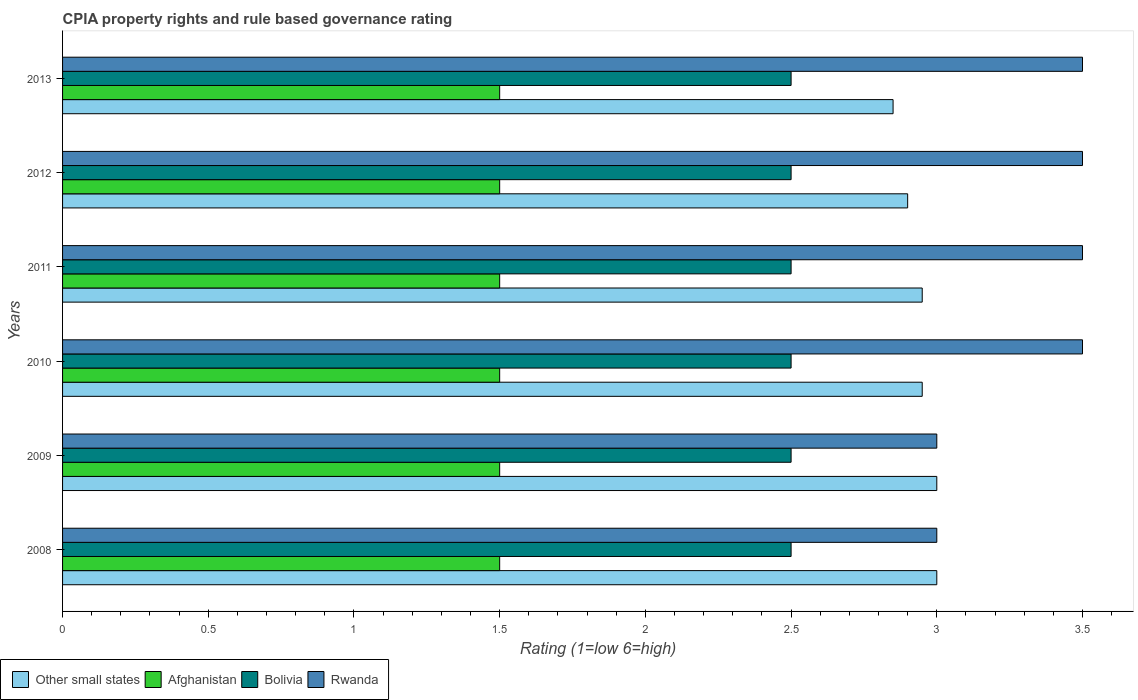How many different coloured bars are there?
Keep it short and to the point. 4. Are the number of bars per tick equal to the number of legend labels?
Your response must be concise. Yes. How many bars are there on the 3rd tick from the bottom?
Your answer should be compact. 4. What is the CPIA rating in Rwanda in 2012?
Offer a terse response. 3.5. Across all years, what is the maximum CPIA rating in Rwanda?
Ensure brevity in your answer.  3.5. Across all years, what is the minimum CPIA rating in Rwanda?
Provide a succinct answer. 3. In which year was the CPIA rating in Rwanda minimum?
Make the answer very short. 2008. What is the total CPIA rating in Other small states in the graph?
Provide a succinct answer. 17.65. What is the difference between the CPIA rating in Other small states in 2011 and the CPIA rating in Bolivia in 2012?
Your answer should be very brief. 0.45. What is the average CPIA rating in Other small states per year?
Keep it short and to the point. 2.94. In the year 2011, what is the difference between the CPIA rating in Rwanda and CPIA rating in Afghanistan?
Make the answer very short. 2. What is the ratio of the CPIA rating in Rwanda in 2010 to that in 2012?
Provide a succinct answer. 1. Is the CPIA rating in Other small states in 2009 less than that in 2012?
Make the answer very short. No. Is the difference between the CPIA rating in Rwanda in 2008 and 2013 greater than the difference between the CPIA rating in Afghanistan in 2008 and 2013?
Offer a very short reply. No. In how many years, is the CPIA rating in Other small states greater than the average CPIA rating in Other small states taken over all years?
Offer a very short reply. 4. What does the 4th bar from the top in 2012 represents?
Your answer should be compact. Other small states. What does the 2nd bar from the bottom in 2012 represents?
Your answer should be very brief. Afghanistan. How many bars are there?
Your answer should be compact. 24. How many years are there in the graph?
Your response must be concise. 6. Does the graph contain grids?
Ensure brevity in your answer.  No. How many legend labels are there?
Offer a terse response. 4. How are the legend labels stacked?
Provide a succinct answer. Horizontal. What is the title of the graph?
Offer a very short reply. CPIA property rights and rule based governance rating. Does "Australia" appear as one of the legend labels in the graph?
Offer a very short reply. No. What is the Rating (1=low 6=high) of Other small states in 2008?
Your response must be concise. 3. What is the Rating (1=low 6=high) in Afghanistan in 2008?
Provide a succinct answer. 1.5. What is the Rating (1=low 6=high) in Other small states in 2009?
Provide a short and direct response. 3. What is the Rating (1=low 6=high) in Afghanistan in 2009?
Make the answer very short. 1.5. What is the Rating (1=low 6=high) in Bolivia in 2009?
Give a very brief answer. 2.5. What is the Rating (1=low 6=high) of Other small states in 2010?
Offer a very short reply. 2.95. What is the Rating (1=low 6=high) of Bolivia in 2010?
Your answer should be compact. 2.5. What is the Rating (1=low 6=high) of Other small states in 2011?
Provide a short and direct response. 2.95. What is the Rating (1=low 6=high) of Bolivia in 2011?
Your answer should be very brief. 2.5. What is the Rating (1=low 6=high) in Rwanda in 2011?
Provide a short and direct response. 3.5. What is the Rating (1=low 6=high) in Other small states in 2012?
Your answer should be compact. 2.9. What is the Rating (1=low 6=high) of Rwanda in 2012?
Offer a very short reply. 3.5. What is the Rating (1=low 6=high) of Other small states in 2013?
Keep it short and to the point. 2.85. What is the Rating (1=low 6=high) of Afghanistan in 2013?
Offer a terse response. 1.5. What is the Rating (1=low 6=high) of Bolivia in 2013?
Give a very brief answer. 2.5. What is the Rating (1=low 6=high) in Rwanda in 2013?
Your answer should be very brief. 3.5. Across all years, what is the maximum Rating (1=low 6=high) of Other small states?
Give a very brief answer. 3. Across all years, what is the maximum Rating (1=low 6=high) of Rwanda?
Provide a succinct answer. 3.5. Across all years, what is the minimum Rating (1=low 6=high) in Other small states?
Your answer should be compact. 2.85. Across all years, what is the minimum Rating (1=low 6=high) of Rwanda?
Your response must be concise. 3. What is the total Rating (1=low 6=high) in Other small states in the graph?
Provide a short and direct response. 17.65. What is the total Rating (1=low 6=high) of Bolivia in the graph?
Provide a short and direct response. 15. What is the total Rating (1=low 6=high) in Rwanda in the graph?
Your response must be concise. 20. What is the difference between the Rating (1=low 6=high) of Other small states in 2008 and that in 2009?
Offer a very short reply. 0. What is the difference between the Rating (1=low 6=high) of Other small states in 2008 and that in 2010?
Your answer should be compact. 0.05. What is the difference between the Rating (1=low 6=high) in Rwanda in 2008 and that in 2010?
Your answer should be compact. -0.5. What is the difference between the Rating (1=low 6=high) of Bolivia in 2008 and that in 2012?
Your answer should be compact. 0. What is the difference between the Rating (1=low 6=high) of Rwanda in 2008 and that in 2012?
Make the answer very short. -0.5. What is the difference between the Rating (1=low 6=high) of Other small states in 2008 and that in 2013?
Keep it short and to the point. 0.15. What is the difference between the Rating (1=low 6=high) in Rwanda in 2008 and that in 2013?
Provide a succinct answer. -0.5. What is the difference between the Rating (1=low 6=high) in Rwanda in 2009 and that in 2010?
Your answer should be compact. -0.5. What is the difference between the Rating (1=low 6=high) in Other small states in 2009 and that in 2011?
Give a very brief answer. 0.05. What is the difference between the Rating (1=low 6=high) of Bolivia in 2009 and that in 2011?
Your answer should be very brief. 0. What is the difference between the Rating (1=low 6=high) in Rwanda in 2009 and that in 2011?
Provide a short and direct response. -0.5. What is the difference between the Rating (1=low 6=high) of Afghanistan in 2009 and that in 2012?
Offer a very short reply. 0. What is the difference between the Rating (1=low 6=high) in Bolivia in 2009 and that in 2012?
Provide a short and direct response. 0. What is the difference between the Rating (1=low 6=high) of Rwanda in 2009 and that in 2012?
Offer a very short reply. -0.5. What is the difference between the Rating (1=low 6=high) in Afghanistan in 2009 and that in 2013?
Make the answer very short. 0. What is the difference between the Rating (1=low 6=high) of Afghanistan in 2010 and that in 2011?
Provide a succinct answer. 0. What is the difference between the Rating (1=low 6=high) in Other small states in 2010 and that in 2012?
Provide a short and direct response. 0.05. What is the difference between the Rating (1=low 6=high) of Other small states in 2010 and that in 2013?
Offer a very short reply. 0.1. What is the difference between the Rating (1=low 6=high) in Afghanistan in 2010 and that in 2013?
Provide a short and direct response. 0. What is the difference between the Rating (1=low 6=high) in Bolivia in 2010 and that in 2013?
Offer a very short reply. 0. What is the difference between the Rating (1=low 6=high) of Rwanda in 2010 and that in 2013?
Offer a terse response. 0. What is the difference between the Rating (1=low 6=high) of Afghanistan in 2011 and that in 2012?
Keep it short and to the point. 0. What is the difference between the Rating (1=low 6=high) of Other small states in 2011 and that in 2013?
Provide a succinct answer. 0.1. What is the difference between the Rating (1=low 6=high) in Afghanistan in 2011 and that in 2013?
Provide a short and direct response. 0. What is the difference between the Rating (1=low 6=high) in Other small states in 2012 and that in 2013?
Make the answer very short. 0.05. What is the difference between the Rating (1=low 6=high) in Bolivia in 2012 and that in 2013?
Ensure brevity in your answer.  0. What is the difference between the Rating (1=low 6=high) of Other small states in 2008 and the Rating (1=low 6=high) of Afghanistan in 2009?
Offer a terse response. 1.5. What is the difference between the Rating (1=low 6=high) of Other small states in 2008 and the Rating (1=low 6=high) of Bolivia in 2009?
Provide a succinct answer. 0.5. What is the difference between the Rating (1=low 6=high) in Afghanistan in 2008 and the Rating (1=low 6=high) in Bolivia in 2009?
Offer a very short reply. -1. What is the difference between the Rating (1=low 6=high) in Bolivia in 2008 and the Rating (1=low 6=high) in Rwanda in 2009?
Offer a terse response. -0.5. What is the difference between the Rating (1=low 6=high) of Other small states in 2008 and the Rating (1=low 6=high) of Afghanistan in 2010?
Provide a short and direct response. 1.5. What is the difference between the Rating (1=low 6=high) of Afghanistan in 2008 and the Rating (1=low 6=high) of Rwanda in 2010?
Your answer should be compact. -2. What is the difference between the Rating (1=low 6=high) of Bolivia in 2008 and the Rating (1=low 6=high) of Rwanda in 2010?
Make the answer very short. -1. What is the difference between the Rating (1=low 6=high) of Other small states in 2008 and the Rating (1=low 6=high) of Afghanistan in 2011?
Your answer should be very brief. 1.5. What is the difference between the Rating (1=low 6=high) in Other small states in 2008 and the Rating (1=low 6=high) in Bolivia in 2011?
Ensure brevity in your answer.  0.5. What is the difference between the Rating (1=low 6=high) in Afghanistan in 2008 and the Rating (1=low 6=high) in Rwanda in 2011?
Give a very brief answer. -2. What is the difference between the Rating (1=low 6=high) in Bolivia in 2008 and the Rating (1=low 6=high) in Rwanda in 2011?
Give a very brief answer. -1. What is the difference between the Rating (1=low 6=high) in Other small states in 2008 and the Rating (1=low 6=high) in Afghanistan in 2012?
Offer a very short reply. 1.5. What is the difference between the Rating (1=low 6=high) in Other small states in 2008 and the Rating (1=low 6=high) in Bolivia in 2012?
Give a very brief answer. 0.5. What is the difference between the Rating (1=low 6=high) of Afghanistan in 2008 and the Rating (1=low 6=high) of Bolivia in 2012?
Give a very brief answer. -1. What is the difference between the Rating (1=low 6=high) of Bolivia in 2008 and the Rating (1=low 6=high) of Rwanda in 2012?
Your answer should be compact. -1. What is the difference between the Rating (1=low 6=high) in Other small states in 2008 and the Rating (1=low 6=high) in Afghanistan in 2013?
Your answer should be compact. 1.5. What is the difference between the Rating (1=low 6=high) in Bolivia in 2008 and the Rating (1=low 6=high) in Rwanda in 2013?
Make the answer very short. -1. What is the difference between the Rating (1=low 6=high) of Other small states in 2009 and the Rating (1=low 6=high) of Afghanistan in 2010?
Provide a short and direct response. 1.5. What is the difference between the Rating (1=low 6=high) in Other small states in 2009 and the Rating (1=low 6=high) in Rwanda in 2010?
Your response must be concise. -0.5. What is the difference between the Rating (1=low 6=high) of Bolivia in 2009 and the Rating (1=low 6=high) of Rwanda in 2010?
Your answer should be compact. -1. What is the difference between the Rating (1=low 6=high) in Other small states in 2009 and the Rating (1=low 6=high) in Rwanda in 2011?
Your response must be concise. -0.5. What is the difference between the Rating (1=low 6=high) in Afghanistan in 2009 and the Rating (1=low 6=high) in Rwanda in 2011?
Offer a terse response. -2. What is the difference between the Rating (1=low 6=high) of Bolivia in 2009 and the Rating (1=low 6=high) of Rwanda in 2011?
Give a very brief answer. -1. What is the difference between the Rating (1=low 6=high) in Other small states in 2009 and the Rating (1=low 6=high) in Afghanistan in 2012?
Give a very brief answer. 1.5. What is the difference between the Rating (1=low 6=high) of Other small states in 2009 and the Rating (1=low 6=high) of Afghanistan in 2013?
Ensure brevity in your answer.  1.5. What is the difference between the Rating (1=low 6=high) in Other small states in 2009 and the Rating (1=low 6=high) in Bolivia in 2013?
Your answer should be very brief. 0.5. What is the difference between the Rating (1=low 6=high) of Other small states in 2009 and the Rating (1=low 6=high) of Rwanda in 2013?
Your answer should be very brief. -0.5. What is the difference between the Rating (1=low 6=high) of Other small states in 2010 and the Rating (1=low 6=high) of Afghanistan in 2011?
Provide a short and direct response. 1.45. What is the difference between the Rating (1=low 6=high) of Other small states in 2010 and the Rating (1=low 6=high) of Bolivia in 2011?
Offer a very short reply. 0.45. What is the difference between the Rating (1=low 6=high) in Other small states in 2010 and the Rating (1=low 6=high) in Rwanda in 2011?
Provide a short and direct response. -0.55. What is the difference between the Rating (1=low 6=high) of Afghanistan in 2010 and the Rating (1=low 6=high) of Bolivia in 2011?
Ensure brevity in your answer.  -1. What is the difference between the Rating (1=low 6=high) in Other small states in 2010 and the Rating (1=low 6=high) in Afghanistan in 2012?
Ensure brevity in your answer.  1.45. What is the difference between the Rating (1=low 6=high) in Other small states in 2010 and the Rating (1=low 6=high) in Bolivia in 2012?
Offer a terse response. 0.45. What is the difference between the Rating (1=low 6=high) of Other small states in 2010 and the Rating (1=low 6=high) of Rwanda in 2012?
Your answer should be very brief. -0.55. What is the difference between the Rating (1=low 6=high) of Bolivia in 2010 and the Rating (1=low 6=high) of Rwanda in 2012?
Your response must be concise. -1. What is the difference between the Rating (1=low 6=high) of Other small states in 2010 and the Rating (1=low 6=high) of Afghanistan in 2013?
Make the answer very short. 1.45. What is the difference between the Rating (1=low 6=high) of Other small states in 2010 and the Rating (1=low 6=high) of Bolivia in 2013?
Give a very brief answer. 0.45. What is the difference between the Rating (1=low 6=high) of Other small states in 2010 and the Rating (1=low 6=high) of Rwanda in 2013?
Keep it short and to the point. -0.55. What is the difference between the Rating (1=low 6=high) in Afghanistan in 2010 and the Rating (1=low 6=high) in Rwanda in 2013?
Give a very brief answer. -2. What is the difference between the Rating (1=low 6=high) of Bolivia in 2010 and the Rating (1=low 6=high) of Rwanda in 2013?
Your response must be concise. -1. What is the difference between the Rating (1=low 6=high) of Other small states in 2011 and the Rating (1=low 6=high) of Afghanistan in 2012?
Offer a very short reply. 1.45. What is the difference between the Rating (1=low 6=high) of Other small states in 2011 and the Rating (1=low 6=high) of Bolivia in 2012?
Provide a short and direct response. 0.45. What is the difference between the Rating (1=low 6=high) of Other small states in 2011 and the Rating (1=low 6=high) of Rwanda in 2012?
Your answer should be very brief. -0.55. What is the difference between the Rating (1=low 6=high) in Afghanistan in 2011 and the Rating (1=low 6=high) in Rwanda in 2012?
Your response must be concise. -2. What is the difference between the Rating (1=low 6=high) of Other small states in 2011 and the Rating (1=low 6=high) of Afghanistan in 2013?
Your answer should be very brief. 1.45. What is the difference between the Rating (1=low 6=high) of Other small states in 2011 and the Rating (1=low 6=high) of Bolivia in 2013?
Offer a terse response. 0.45. What is the difference between the Rating (1=low 6=high) in Other small states in 2011 and the Rating (1=low 6=high) in Rwanda in 2013?
Offer a terse response. -0.55. What is the difference between the Rating (1=low 6=high) in Afghanistan in 2011 and the Rating (1=low 6=high) in Bolivia in 2013?
Offer a terse response. -1. What is the difference between the Rating (1=low 6=high) in Afghanistan in 2011 and the Rating (1=low 6=high) in Rwanda in 2013?
Provide a succinct answer. -2. What is the difference between the Rating (1=low 6=high) in Bolivia in 2011 and the Rating (1=low 6=high) in Rwanda in 2013?
Offer a terse response. -1. What is the difference between the Rating (1=low 6=high) in Other small states in 2012 and the Rating (1=low 6=high) in Afghanistan in 2013?
Provide a short and direct response. 1.4. What is the difference between the Rating (1=low 6=high) of Afghanistan in 2012 and the Rating (1=low 6=high) of Bolivia in 2013?
Offer a very short reply. -1. What is the difference between the Rating (1=low 6=high) in Afghanistan in 2012 and the Rating (1=low 6=high) in Rwanda in 2013?
Your response must be concise. -2. What is the average Rating (1=low 6=high) of Other small states per year?
Provide a succinct answer. 2.94. What is the average Rating (1=low 6=high) of Afghanistan per year?
Provide a succinct answer. 1.5. What is the average Rating (1=low 6=high) of Bolivia per year?
Provide a succinct answer. 2.5. What is the average Rating (1=low 6=high) of Rwanda per year?
Keep it short and to the point. 3.33. In the year 2008, what is the difference between the Rating (1=low 6=high) of Other small states and Rating (1=low 6=high) of Bolivia?
Keep it short and to the point. 0.5. In the year 2008, what is the difference between the Rating (1=low 6=high) of Afghanistan and Rating (1=low 6=high) of Bolivia?
Provide a short and direct response. -1. In the year 2008, what is the difference between the Rating (1=low 6=high) of Afghanistan and Rating (1=low 6=high) of Rwanda?
Give a very brief answer. -1.5. In the year 2008, what is the difference between the Rating (1=low 6=high) in Bolivia and Rating (1=low 6=high) in Rwanda?
Offer a terse response. -0.5. In the year 2009, what is the difference between the Rating (1=low 6=high) in Other small states and Rating (1=low 6=high) in Bolivia?
Make the answer very short. 0.5. In the year 2009, what is the difference between the Rating (1=low 6=high) in Afghanistan and Rating (1=low 6=high) in Bolivia?
Make the answer very short. -1. In the year 2010, what is the difference between the Rating (1=low 6=high) in Other small states and Rating (1=low 6=high) in Afghanistan?
Give a very brief answer. 1.45. In the year 2010, what is the difference between the Rating (1=low 6=high) in Other small states and Rating (1=low 6=high) in Bolivia?
Your answer should be very brief. 0.45. In the year 2010, what is the difference between the Rating (1=low 6=high) of Other small states and Rating (1=low 6=high) of Rwanda?
Provide a succinct answer. -0.55. In the year 2010, what is the difference between the Rating (1=low 6=high) in Bolivia and Rating (1=low 6=high) in Rwanda?
Offer a very short reply. -1. In the year 2011, what is the difference between the Rating (1=low 6=high) in Other small states and Rating (1=low 6=high) in Afghanistan?
Give a very brief answer. 1.45. In the year 2011, what is the difference between the Rating (1=low 6=high) in Other small states and Rating (1=low 6=high) in Bolivia?
Offer a terse response. 0.45. In the year 2011, what is the difference between the Rating (1=low 6=high) of Other small states and Rating (1=low 6=high) of Rwanda?
Keep it short and to the point. -0.55. In the year 2011, what is the difference between the Rating (1=low 6=high) in Afghanistan and Rating (1=low 6=high) in Bolivia?
Provide a short and direct response. -1. In the year 2011, what is the difference between the Rating (1=low 6=high) in Afghanistan and Rating (1=low 6=high) in Rwanda?
Your answer should be compact. -2. In the year 2012, what is the difference between the Rating (1=low 6=high) of Other small states and Rating (1=low 6=high) of Rwanda?
Ensure brevity in your answer.  -0.6. In the year 2012, what is the difference between the Rating (1=low 6=high) of Afghanistan and Rating (1=low 6=high) of Rwanda?
Make the answer very short. -2. In the year 2013, what is the difference between the Rating (1=low 6=high) in Other small states and Rating (1=low 6=high) in Afghanistan?
Ensure brevity in your answer.  1.35. In the year 2013, what is the difference between the Rating (1=low 6=high) of Other small states and Rating (1=low 6=high) of Rwanda?
Provide a succinct answer. -0.65. In the year 2013, what is the difference between the Rating (1=low 6=high) in Afghanistan and Rating (1=low 6=high) in Bolivia?
Give a very brief answer. -1. In the year 2013, what is the difference between the Rating (1=low 6=high) of Afghanistan and Rating (1=low 6=high) of Rwanda?
Make the answer very short. -2. What is the ratio of the Rating (1=low 6=high) in Bolivia in 2008 to that in 2009?
Keep it short and to the point. 1. What is the ratio of the Rating (1=low 6=high) of Rwanda in 2008 to that in 2009?
Provide a succinct answer. 1. What is the ratio of the Rating (1=low 6=high) in Other small states in 2008 to that in 2010?
Keep it short and to the point. 1.02. What is the ratio of the Rating (1=low 6=high) in Bolivia in 2008 to that in 2010?
Give a very brief answer. 1. What is the ratio of the Rating (1=low 6=high) of Other small states in 2008 to that in 2011?
Give a very brief answer. 1.02. What is the ratio of the Rating (1=low 6=high) of Bolivia in 2008 to that in 2011?
Offer a very short reply. 1. What is the ratio of the Rating (1=low 6=high) of Other small states in 2008 to that in 2012?
Keep it short and to the point. 1.03. What is the ratio of the Rating (1=low 6=high) in Afghanistan in 2008 to that in 2012?
Give a very brief answer. 1. What is the ratio of the Rating (1=low 6=high) in Other small states in 2008 to that in 2013?
Provide a short and direct response. 1.05. What is the ratio of the Rating (1=low 6=high) of Afghanistan in 2008 to that in 2013?
Give a very brief answer. 1. What is the ratio of the Rating (1=low 6=high) of Bolivia in 2008 to that in 2013?
Give a very brief answer. 1. What is the ratio of the Rating (1=low 6=high) of Other small states in 2009 to that in 2010?
Your answer should be very brief. 1.02. What is the ratio of the Rating (1=low 6=high) in Afghanistan in 2009 to that in 2010?
Offer a very short reply. 1. What is the ratio of the Rating (1=low 6=high) of Bolivia in 2009 to that in 2010?
Keep it short and to the point. 1. What is the ratio of the Rating (1=low 6=high) of Other small states in 2009 to that in 2011?
Keep it short and to the point. 1.02. What is the ratio of the Rating (1=low 6=high) of Afghanistan in 2009 to that in 2011?
Your response must be concise. 1. What is the ratio of the Rating (1=low 6=high) in Other small states in 2009 to that in 2012?
Provide a short and direct response. 1.03. What is the ratio of the Rating (1=low 6=high) in Bolivia in 2009 to that in 2012?
Keep it short and to the point. 1. What is the ratio of the Rating (1=low 6=high) in Other small states in 2009 to that in 2013?
Offer a terse response. 1.05. What is the ratio of the Rating (1=low 6=high) of Bolivia in 2009 to that in 2013?
Offer a terse response. 1. What is the ratio of the Rating (1=low 6=high) of Rwanda in 2009 to that in 2013?
Offer a very short reply. 0.86. What is the ratio of the Rating (1=low 6=high) of Afghanistan in 2010 to that in 2011?
Keep it short and to the point. 1. What is the ratio of the Rating (1=low 6=high) in Rwanda in 2010 to that in 2011?
Offer a very short reply. 1. What is the ratio of the Rating (1=low 6=high) in Other small states in 2010 to that in 2012?
Provide a short and direct response. 1.02. What is the ratio of the Rating (1=low 6=high) in Bolivia in 2010 to that in 2012?
Your answer should be very brief. 1. What is the ratio of the Rating (1=low 6=high) in Other small states in 2010 to that in 2013?
Your answer should be compact. 1.04. What is the ratio of the Rating (1=low 6=high) of Afghanistan in 2010 to that in 2013?
Your answer should be compact. 1. What is the ratio of the Rating (1=low 6=high) in Bolivia in 2010 to that in 2013?
Your response must be concise. 1. What is the ratio of the Rating (1=low 6=high) of Other small states in 2011 to that in 2012?
Give a very brief answer. 1.02. What is the ratio of the Rating (1=low 6=high) of Rwanda in 2011 to that in 2012?
Offer a very short reply. 1. What is the ratio of the Rating (1=low 6=high) of Other small states in 2011 to that in 2013?
Provide a short and direct response. 1.04. What is the ratio of the Rating (1=low 6=high) of Other small states in 2012 to that in 2013?
Your answer should be compact. 1.02. What is the ratio of the Rating (1=low 6=high) in Afghanistan in 2012 to that in 2013?
Provide a short and direct response. 1. What is the ratio of the Rating (1=low 6=high) in Rwanda in 2012 to that in 2013?
Keep it short and to the point. 1. What is the difference between the highest and the second highest Rating (1=low 6=high) in Other small states?
Offer a terse response. 0. What is the difference between the highest and the lowest Rating (1=low 6=high) in Other small states?
Offer a terse response. 0.15. What is the difference between the highest and the lowest Rating (1=low 6=high) of Afghanistan?
Provide a succinct answer. 0. What is the difference between the highest and the lowest Rating (1=low 6=high) of Rwanda?
Offer a terse response. 0.5. 